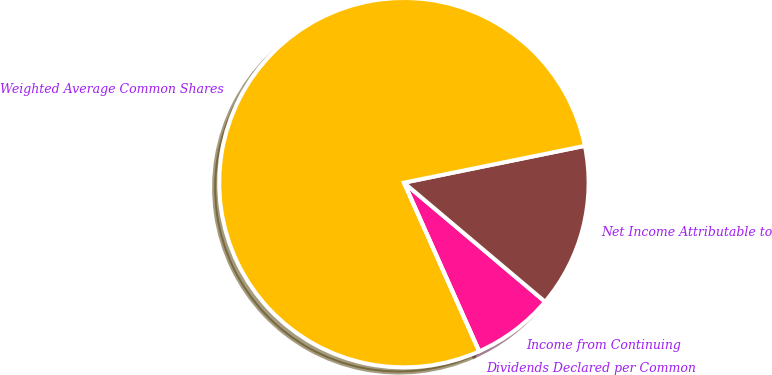Convert chart. <chart><loc_0><loc_0><loc_500><loc_500><pie_chart><fcel>Income from Continuing<fcel>Net Income Attributable to<fcel>Weighted Average Common Shares<fcel>Dividends Declared per Common<nl><fcel>7.17%<fcel>14.35%<fcel>78.48%<fcel>0.0%<nl></chart> 